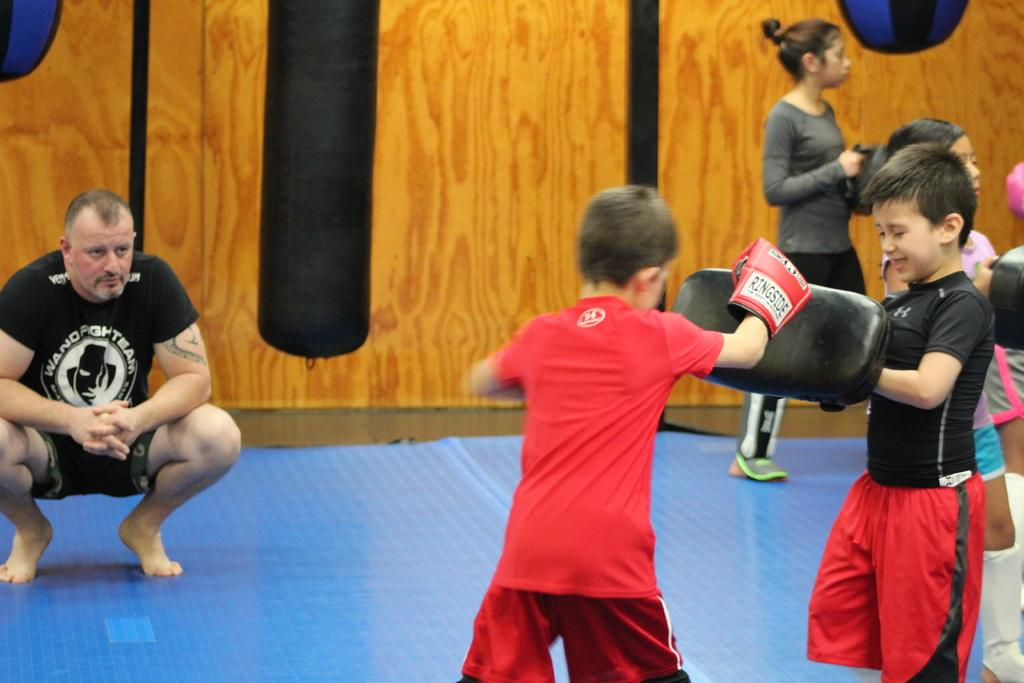Who or what can be seen in the image? There are people in the image. How are the people positioned in the image? The people are scattered throughout the image. What is one feature of the image's background? There is a wall in the image. What rule does the person's nose follow in the image? There is no specific rule mentioned for the person's nose in the image, and the image does not focus on the nose. 